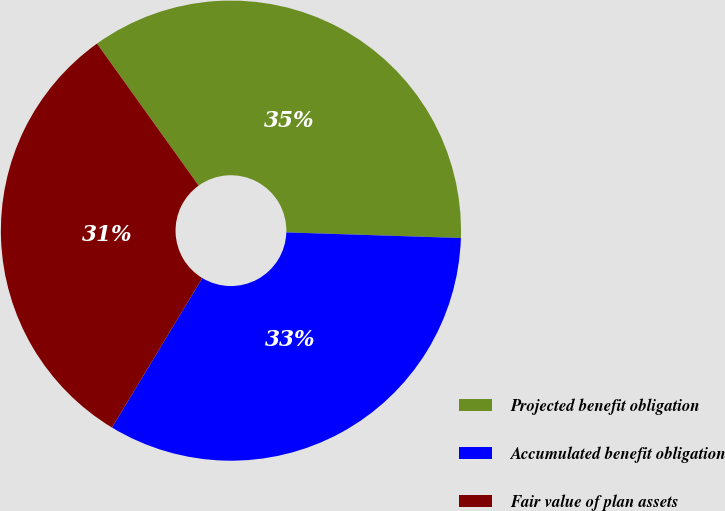Convert chart. <chart><loc_0><loc_0><loc_500><loc_500><pie_chart><fcel>Projected benefit obligation<fcel>Accumulated benefit obligation<fcel>Fair value of plan assets<nl><fcel>35.4%<fcel>33.14%<fcel>31.46%<nl></chart> 